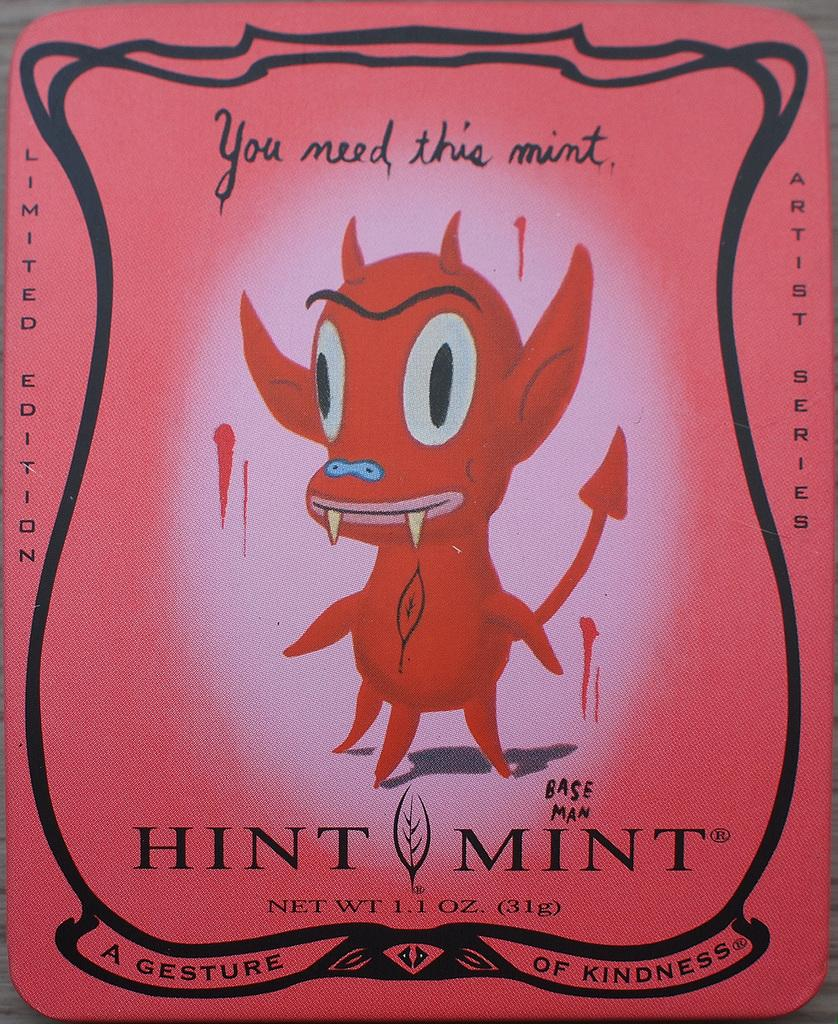What is present on the poster in the image? There is a poster in the image that contains an image of a cartoon. What else can be seen on the poster besides the cartoon image? There is text on the poster. What reason does the family have for walking on the road in the image? There is no family or road present in the image; it only features a poster with a cartoon image and text. 